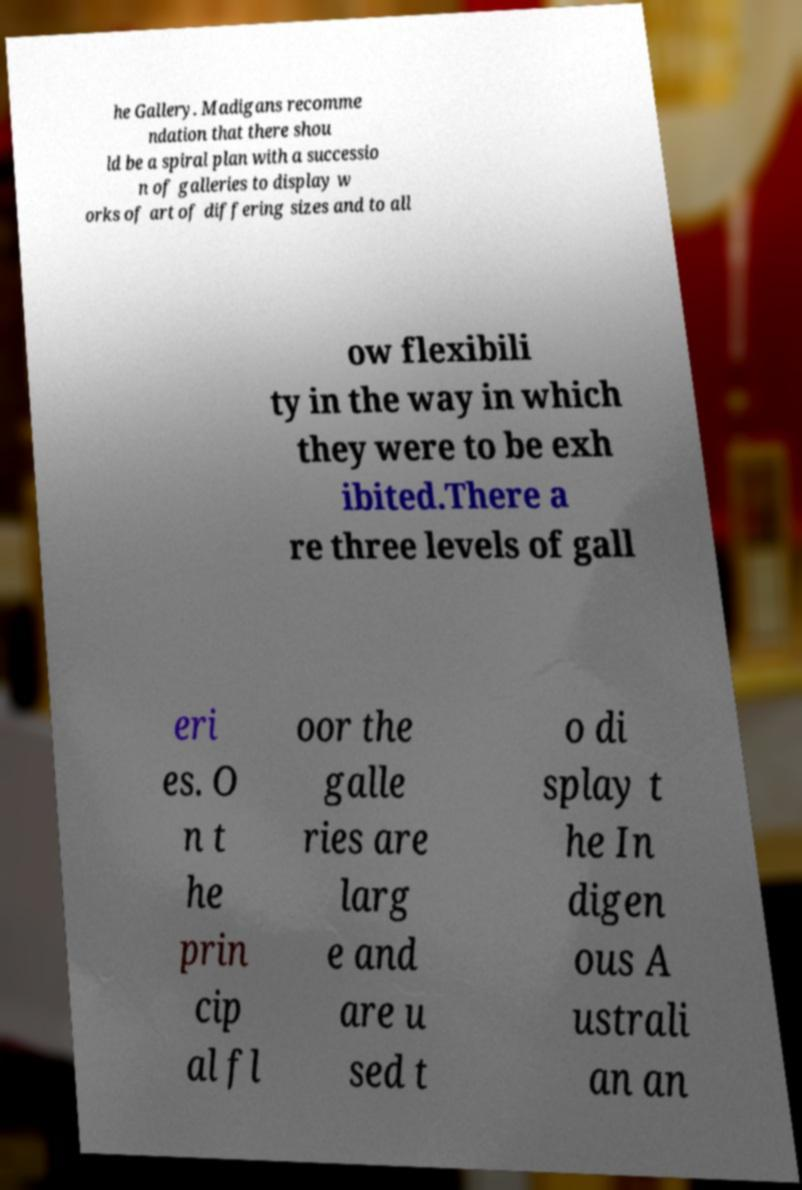Can you read and provide the text displayed in the image?This photo seems to have some interesting text. Can you extract and type it out for me? he Gallery. Madigans recomme ndation that there shou ld be a spiral plan with a successio n of galleries to display w orks of art of differing sizes and to all ow flexibili ty in the way in which they were to be exh ibited.There a re three levels of gall eri es. O n t he prin cip al fl oor the galle ries are larg e and are u sed t o di splay t he In digen ous A ustrali an an 